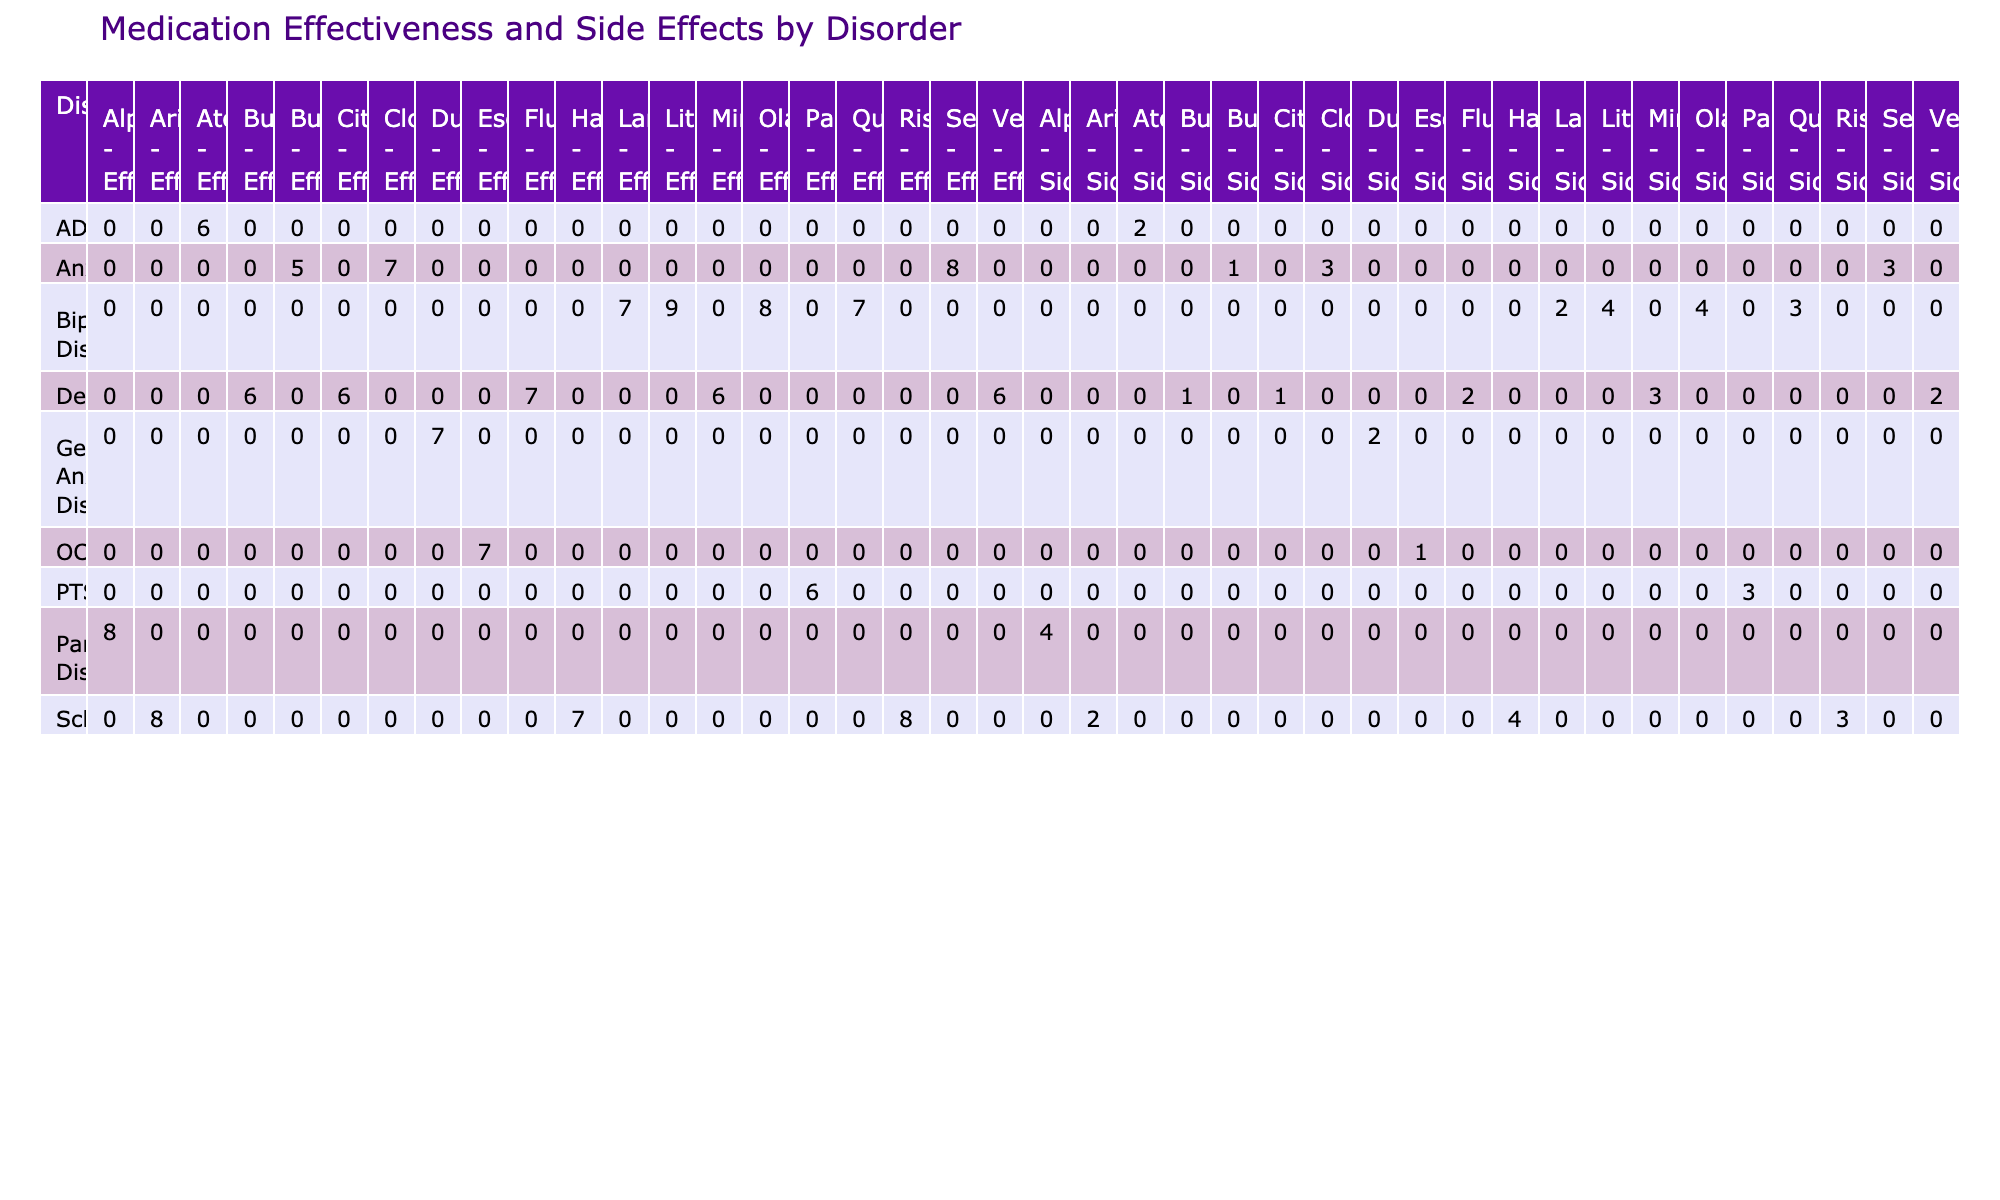What is the effectiveness rating for Fluoxetine used in treating Depression? The effectiveness rating for Fluoxetine in treating Depression can be found directly in the table. Looking under the 'Disorder' column for Depression, the corresponding effectiveness rating for Fluoxetine is listed as 7.
Answer: 7 What side effect severity is reported for Sertraline in treating Anxiety? By locating Sertraline under the 'Anxiety' disorder in the table, we see the side effect severity value associated with it, which is 3.
Answer: 3 Which medication has the highest effectiveness rating for Bipolar Disorder? For Bipolar Disorder, we compare the effectiveness ratings of Lithium, Quetiapine, and Olanzapine. The effectiveness ratings are 9, 7, and 8 respectively. Thus, Lithium has the highest effectiveness rating of 9.
Answer: Lithium Is the average side effect severity of medications used to treat Depression higher than that of medications for Anxiety? To find this, we first identify the side effect severities for Depression: 2 (Fluoxetine), 2 (Venlafaxine), 1 (Bupropion), and 1 (Citalopram), which sums to 6. There are 4 medications, making the average 6/4 = 1.5. Then for Anxiety: 3 (Sertraline), 3 (Clonazepam), and 1 (Buspirone), which sums to 7. There are 3 medications, making the average 7/3 ≈ 2.33. Since 1.5 < 2.33, the average severity for Anxiety is higher.
Answer: Yes Are there any medications with side effect severity ratings of 4? We look through the side effect severity ratings for all medications. Only Alprazolam, Lithium, and Olanzapine have a side effect severity of 4. Thus, we confirm there are medications with this rating.
Answer: Yes What is the average effectiveness rating for medications classified under Schizophrenia? We first compile the effectiveness ratings for the medications: 8 (Risperidone), 8 (Aripiprazole), and 7 (Haloperidol). Summing these gives us 8 + 8 + 7 = 23. There are 3 medications, so the average effectiveness rating is 23/3 ≈ 7.67.
Answer: 7.67 Which gender has the higher average effectiveness rating for medications treating Depression? We analyze the effectiveness ratings for Depression, separating by gender. Females have ratings of 7 (Fluoxetine), 6 (Bupropion), and 6 (Mirtazapine), averaging to (7+6+6)/3 = 6.33. Males have ratings of 6 (Venlafaxine), averaging 6. Thus, the male and female averages are 6 and 6.33 respectively, confirming females have a higher average effectiveness rating.
Answer: Female How many medications are prescribed for PTSD and what are their side effect severities? In the table, we see Paroxetine listed under PTSD with a side effect severity rating of 3. Since Paroxetine is the only medication listed, there is just one medication prescribed for PTSD with a severity of 3.
Answer: 1 medication, severity 3 